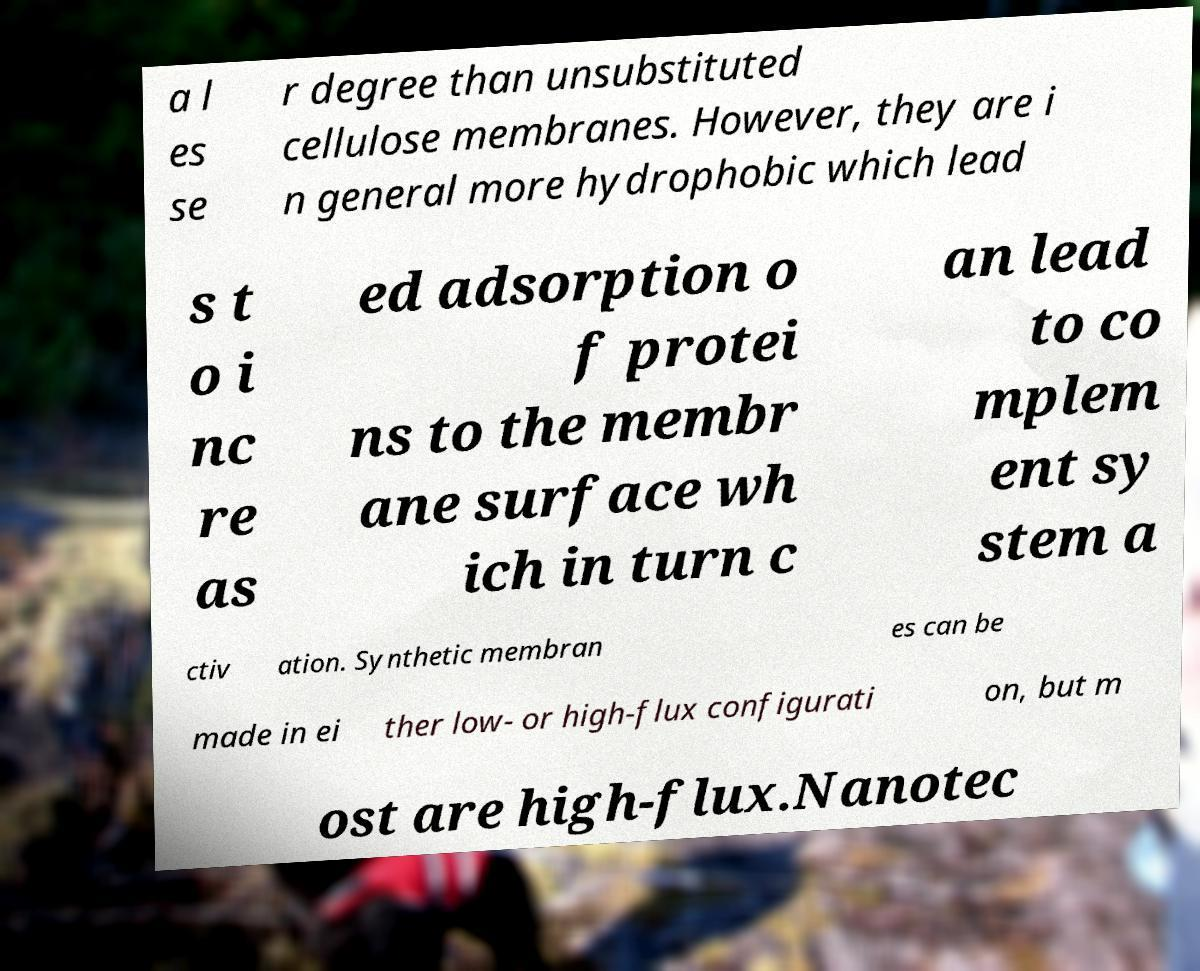Could you assist in decoding the text presented in this image and type it out clearly? a l es se r degree than unsubstituted cellulose membranes. However, they are i n general more hydrophobic which lead s t o i nc re as ed adsorption o f protei ns to the membr ane surface wh ich in turn c an lead to co mplem ent sy stem a ctiv ation. Synthetic membran es can be made in ei ther low- or high-flux configurati on, but m ost are high-flux.Nanotec 